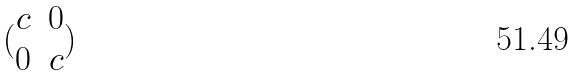Convert formula to latex. <formula><loc_0><loc_0><loc_500><loc_500>( \begin{matrix} c & 0 \\ 0 & c \end{matrix} )</formula> 